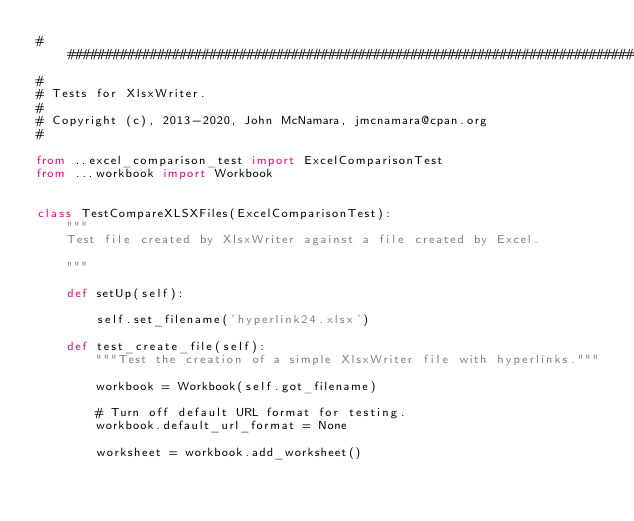Convert code to text. <code><loc_0><loc_0><loc_500><loc_500><_Python_>###############################################################################
#
# Tests for XlsxWriter.
#
# Copyright (c), 2013-2020, John McNamara, jmcnamara@cpan.org
#

from ..excel_comparison_test import ExcelComparisonTest
from ...workbook import Workbook


class TestCompareXLSXFiles(ExcelComparisonTest):
    """
    Test file created by XlsxWriter against a file created by Excel.

    """

    def setUp(self):

        self.set_filename('hyperlink24.xlsx')

    def test_create_file(self):
        """Test the creation of a simple XlsxWriter file with hyperlinks."""

        workbook = Workbook(self.got_filename)

        # Turn off default URL format for testing.
        workbook.default_url_format = None

        worksheet = workbook.add_worksheet()
</code> 